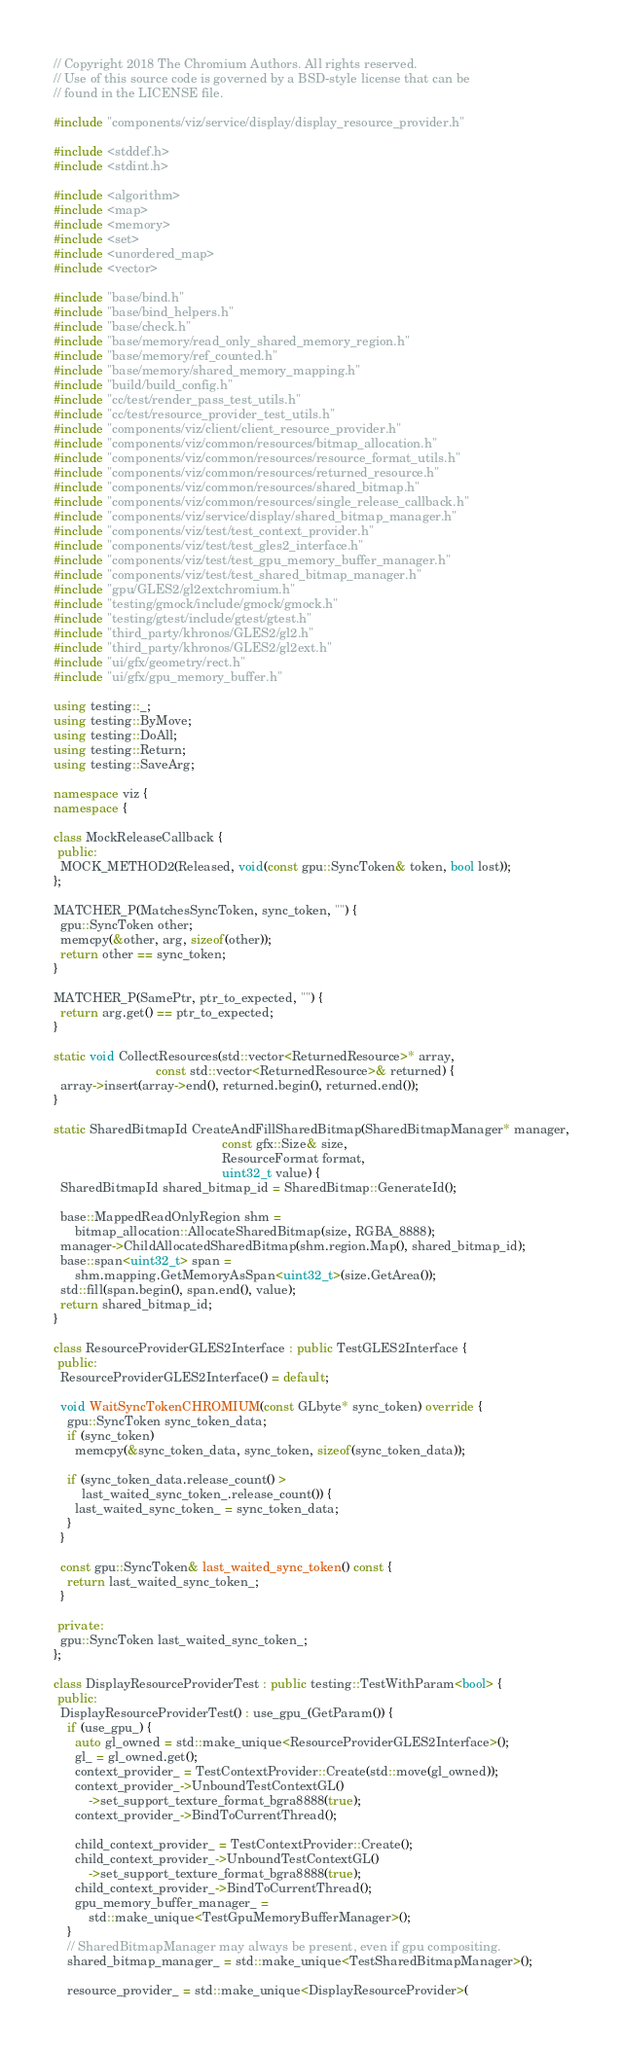<code> <loc_0><loc_0><loc_500><loc_500><_C++_>// Copyright 2018 The Chromium Authors. All rights reserved.
// Use of this source code is governed by a BSD-style license that can be
// found in the LICENSE file.

#include "components/viz/service/display/display_resource_provider.h"

#include <stddef.h>
#include <stdint.h>

#include <algorithm>
#include <map>
#include <memory>
#include <set>
#include <unordered_map>
#include <vector>

#include "base/bind.h"
#include "base/bind_helpers.h"
#include "base/check.h"
#include "base/memory/read_only_shared_memory_region.h"
#include "base/memory/ref_counted.h"
#include "base/memory/shared_memory_mapping.h"
#include "build/build_config.h"
#include "cc/test/render_pass_test_utils.h"
#include "cc/test/resource_provider_test_utils.h"
#include "components/viz/client/client_resource_provider.h"
#include "components/viz/common/resources/bitmap_allocation.h"
#include "components/viz/common/resources/resource_format_utils.h"
#include "components/viz/common/resources/returned_resource.h"
#include "components/viz/common/resources/shared_bitmap.h"
#include "components/viz/common/resources/single_release_callback.h"
#include "components/viz/service/display/shared_bitmap_manager.h"
#include "components/viz/test/test_context_provider.h"
#include "components/viz/test/test_gles2_interface.h"
#include "components/viz/test/test_gpu_memory_buffer_manager.h"
#include "components/viz/test/test_shared_bitmap_manager.h"
#include "gpu/GLES2/gl2extchromium.h"
#include "testing/gmock/include/gmock/gmock.h"
#include "testing/gtest/include/gtest/gtest.h"
#include "third_party/khronos/GLES2/gl2.h"
#include "third_party/khronos/GLES2/gl2ext.h"
#include "ui/gfx/geometry/rect.h"
#include "ui/gfx/gpu_memory_buffer.h"

using testing::_;
using testing::ByMove;
using testing::DoAll;
using testing::Return;
using testing::SaveArg;

namespace viz {
namespace {

class MockReleaseCallback {
 public:
  MOCK_METHOD2(Released, void(const gpu::SyncToken& token, bool lost));
};

MATCHER_P(MatchesSyncToken, sync_token, "") {
  gpu::SyncToken other;
  memcpy(&other, arg, sizeof(other));
  return other == sync_token;
}

MATCHER_P(SamePtr, ptr_to_expected, "") {
  return arg.get() == ptr_to_expected;
}

static void CollectResources(std::vector<ReturnedResource>* array,
                             const std::vector<ReturnedResource>& returned) {
  array->insert(array->end(), returned.begin(), returned.end());
}

static SharedBitmapId CreateAndFillSharedBitmap(SharedBitmapManager* manager,
                                                const gfx::Size& size,
                                                ResourceFormat format,
                                                uint32_t value) {
  SharedBitmapId shared_bitmap_id = SharedBitmap::GenerateId();

  base::MappedReadOnlyRegion shm =
      bitmap_allocation::AllocateSharedBitmap(size, RGBA_8888);
  manager->ChildAllocatedSharedBitmap(shm.region.Map(), shared_bitmap_id);
  base::span<uint32_t> span =
      shm.mapping.GetMemoryAsSpan<uint32_t>(size.GetArea());
  std::fill(span.begin(), span.end(), value);
  return shared_bitmap_id;
}

class ResourceProviderGLES2Interface : public TestGLES2Interface {
 public:
  ResourceProviderGLES2Interface() = default;

  void WaitSyncTokenCHROMIUM(const GLbyte* sync_token) override {
    gpu::SyncToken sync_token_data;
    if (sync_token)
      memcpy(&sync_token_data, sync_token, sizeof(sync_token_data));

    if (sync_token_data.release_count() >
        last_waited_sync_token_.release_count()) {
      last_waited_sync_token_ = sync_token_data;
    }
  }

  const gpu::SyncToken& last_waited_sync_token() const {
    return last_waited_sync_token_;
  }

 private:
  gpu::SyncToken last_waited_sync_token_;
};

class DisplayResourceProviderTest : public testing::TestWithParam<bool> {
 public:
  DisplayResourceProviderTest() : use_gpu_(GetParam()) {
    if (use_gpu_) {
      auto gl_owned = std::make_unique<ResourceProviderGLES2Interface>();
      gl_ = gl_owned.get();
      context_provider_ = TestContextProvider::Create(std::move(gl_owned));
      context_provider_->UnboundTestContextGL()
          ->set_support_texture_format_bgra8888(true);
      context_provider_->BindToCurrentThread();

      child_context_provider_ = TestContextProvider::Create();
      child_context_provider_->UnboundTestContextGL()
          ->set_support_texture_format_bgra8888(true);
      child_context_provider_->BindToCurrentThread();
      gpu_memory_buffer_manager_ =
          std::make_unique<TestGpuMemoryBufferManager>();
    }
    // SharedBitmapManager may always be present, even if gpu compositing.
    shared_bitmap_manager_ = std::make_unique<TestSharedBitmapManager>();

    resource_provider_ = std::make_unique<DisplayResourceProvider>(</code> 